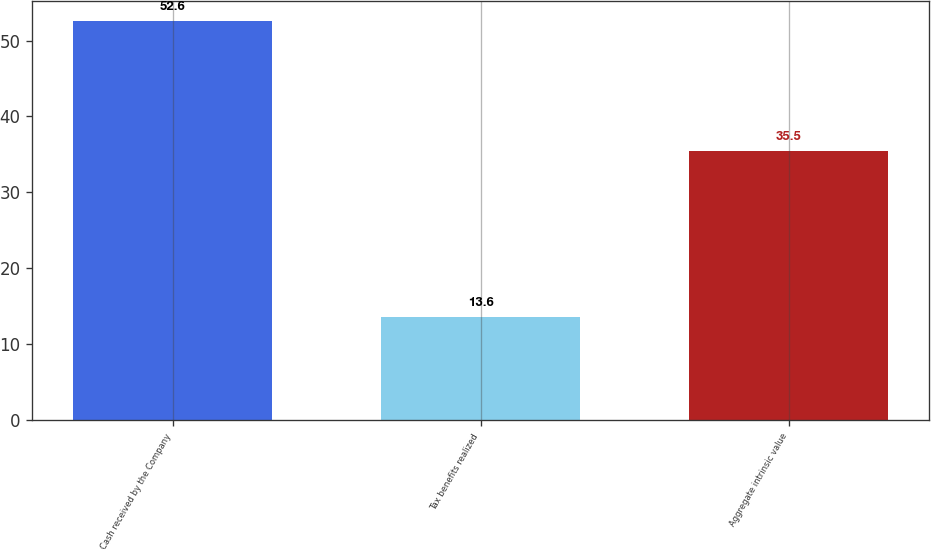<chart> <loc_0><loc_0><loc_500><loc_500><bar_chart><fcel>Cash received by the Company<fcel>Tax benefits realized<fcel>Aggregate intrinsic value<nl><fcel>52.6<fcel>13.6<fcel>35.5<nl></chart> 